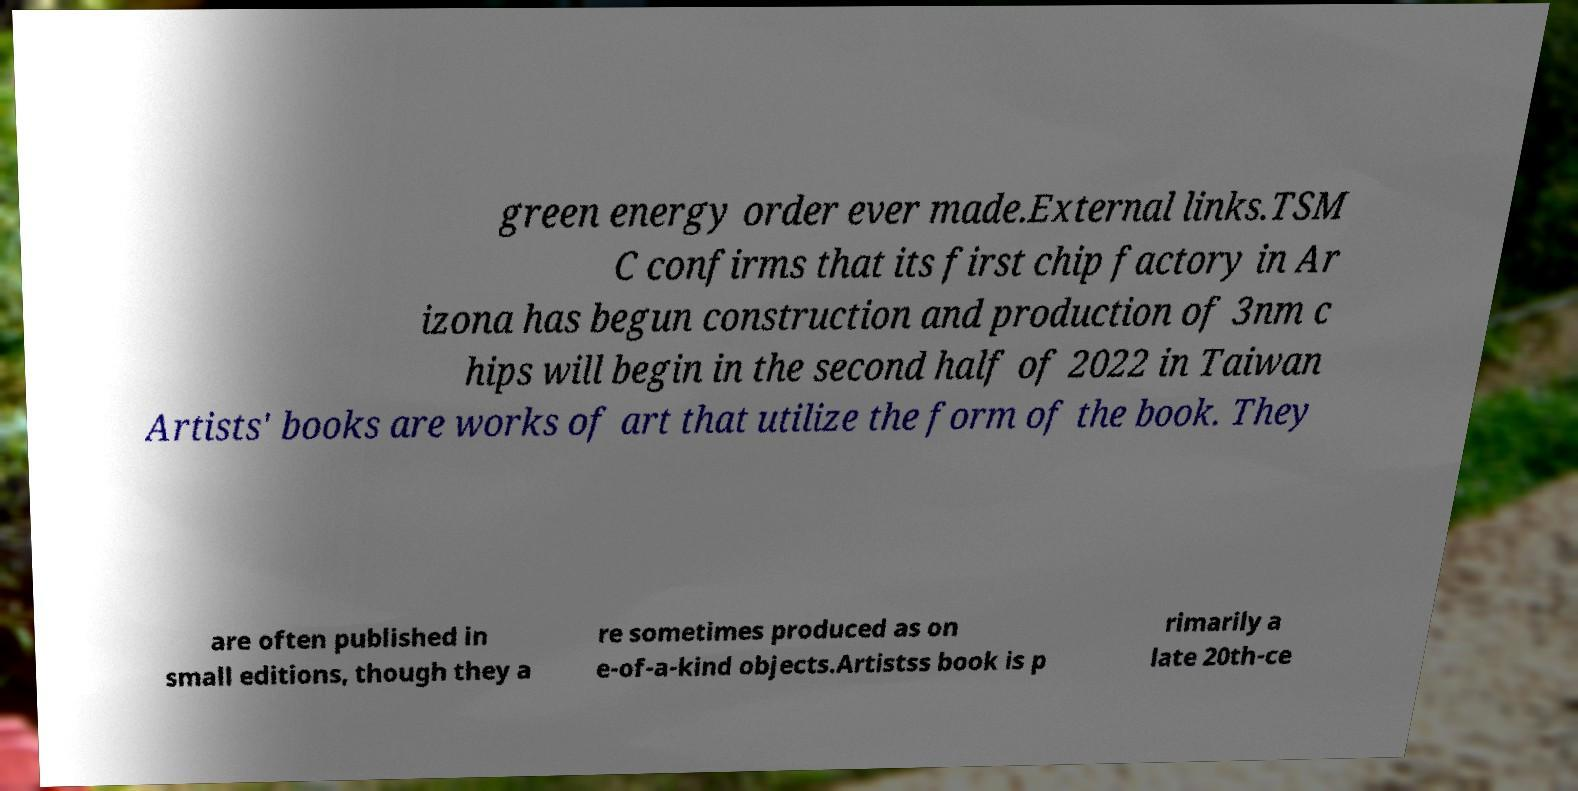Can you read and provide the text displayed in the image?This photo seems to have some interesting text. Can you extract and type it out for me? green energy order ever made.External links.TSM C confirms that its first chip factory in Ar izona has begun construction and production of 3nm c hips will begin in the second half of 2022 in Taiwan Artists' books are works of art that utilize the form of the book. They are often published in small editions, though they a re sometimes produced as on e-of-a-kind objects.Artistss book is p rimarily a late 20th-ce 